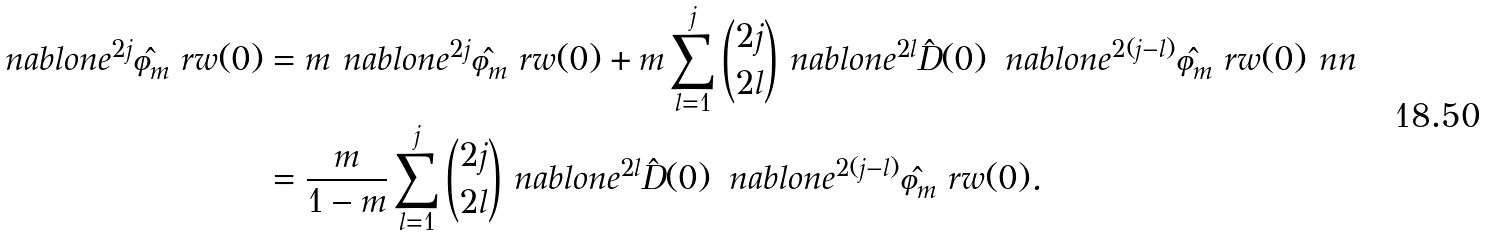Convert formula to latex. <formula><loc_0><loc_0><loc_500><loc_500>\ n a b l o n e ^ { 2 j } \hat { \varphi } _ { m } ^ { \ } r w ( 0 ) & = m \ n a b l o n e ^ { 2 j } \hat { \varphi } _ { m } ^ { \ } r w ( 0 ) + m \sum _ { l = 1 } ^ { j } \binom { 2 j } { 2 l } \ n a b l o n e ^ { 2 l } \hat { D } ( 0 ) \, \ n a b l o n e ^ { 2 ( j - l ) } \hat { \varphi } _ { m } ^ { \ } r w ( 0 ) \ n n \\ & = \frac { m } { 1 - m } \sum _ { l = 1 } ^ { j } \binom { 2 j } { 2 l } \ n a b l o n e ^ { 2 l } \hat { D } ( 0 ) \, \ n a b l o n e ^ { 2 ( j - l ) } \hat { \varphi } _ { m } ^ { \ } r w ( 0 ) .</formula> 